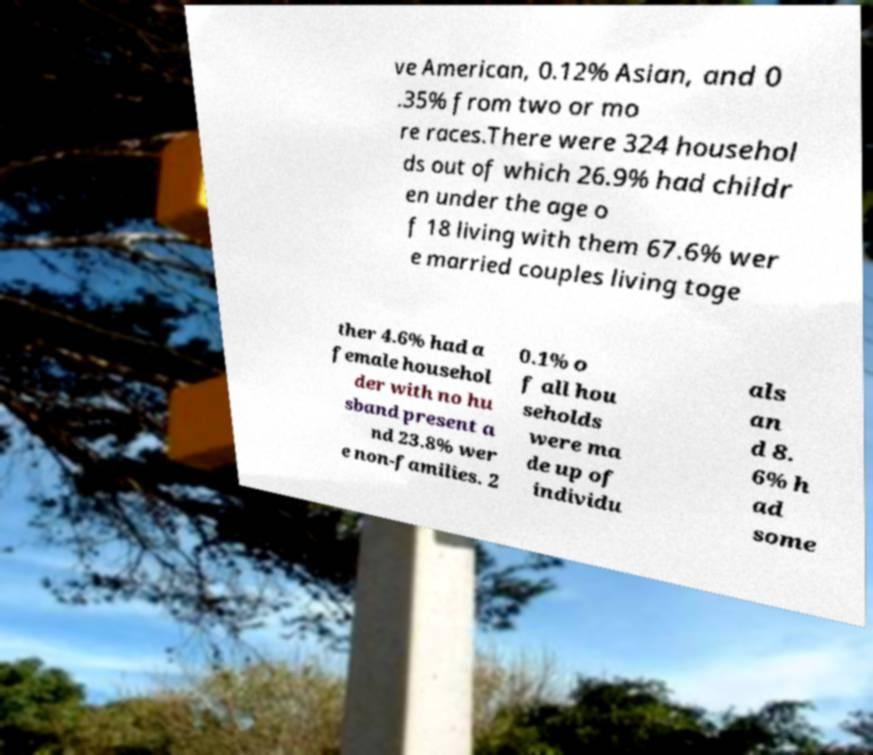What messages or text are displayed in this image? I need them in a readable, typed format. ve American, 0.12% Asian, and 0 .35% from two or mo re races.There were 324 househol ds out of which 26.9% had childr en under the age o f 18 living with them 67.6% wer e married couples living toge ther 4.6% had a female househol der with no hu sband present a nd 23.8% wer e non-families. 2 0.1% o f all hou seholds were ma de up of individu als an d 8. 6% h ad some 